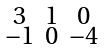Convert formula to latex. <formula><loc_0><loc_0><loc_500><loc_500>\begin{smallmatrix} 3 & 1 & 0 \\ - 1 & 0 & - 4 \end{smallmatrix}</formula> 